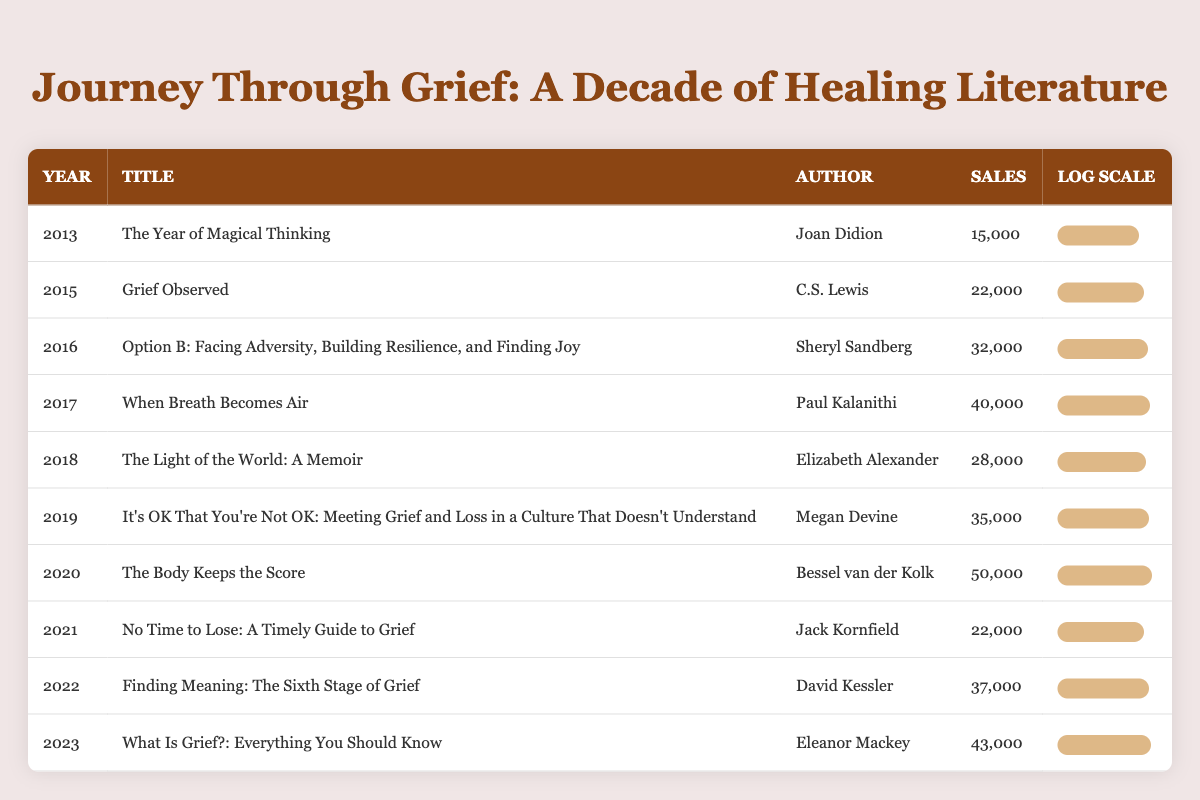What was the sales figure for "The Body Keeps the Score"? In the table, locate the entry for the year 2020 and check the "Sales" column. The sales figure listed next to "The Body Keeps the Score" is 50,000.
Answer: 50,000 Which book had the lowest sales in this dataset? Inspect the "Sales" column for all entries. The book with the lowest sales is "The Year of Magical Thinking" from 2013, which had 15,000.
Answer: The Year of Magical Thinking What is the total sales of books from 2019 to 2023? Identify the sales figures for each year from 2019 to 2023: 35,000 (2019) + 50,000 (2020) + 22,000 (2021) + 37,000 (2022) + 43,000 (2023). Adding these gives 187,000.
Answer: 187,000 Was there an increase in sales from 2021 to 2022? Compare the sales figures for these years: Sales in 2021 were 22,000, and in 2022, they were 37,000. The difference (37,000 - 22,000) shows an increase of 15,000.
Answer: Yes How many books had sales over 30,000? Review the sales figures for all years: The books with sales over 30,000 are: "Grief Observed" (22,000), "Option B" (32,000), "When Breath Becomes Air" (40,000), "It's OK That You're Not OK" (35,000), "The Body Keeps the Score" (50,000), "Finding Meaning" (37,000), and "What Is Grief?" (43,000). Counting these results in 6 books.
Answer: 6 What year had the highest sales, and what was it? Identify the highest number in the "Sales" column. The highest sales of 50,000 occurred in 2020, associated with "The Body Keeps the Score."
Answer: 2020, 50,000 What is the average sales figure across all books listed? To find the average, first sum all sales figures: (15,000 + 22,000 + 32,000 + 40,000 + 28,000 + 35,000 + 50,000 + 22,000 + 37,000 + 43,000) =  382,000. Divide by the number of books (10), giving an average of 38,200.
Answer: 38,200 Is "Finding Meaning" the only book published after 2020? Check the list of titles and their publication years. "Finding Meaning" was published in 2022, but "What Is Grief?" was published in 2023. Thus, there are two books published after 2020.
Answer: No Was there a decrease in sales from 2017 to 2018? Compare the sales figures for 2017 (40,000) and 2018 (28,000). The difference of 12,000 (28,000 - 40,000) indicates a decrease in sales.
Answer: Yes 